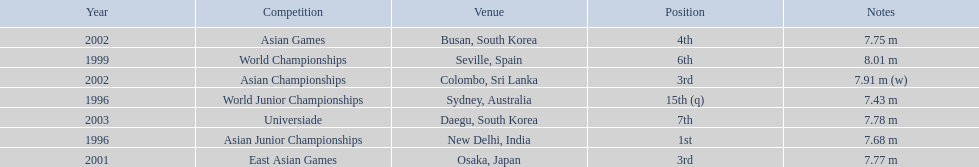What are all of the competitions? World Junior Championships, Asian Junior Championships, World Championships, East Asian Games, Asian Championships, Asian Games, Universiade. What was his positions in these competitions? 15th (q), 1st, 6th, 3rd, 3rd, 4th, 7th. And during which competition did he reach 1st place? Asian Junior Championships. 